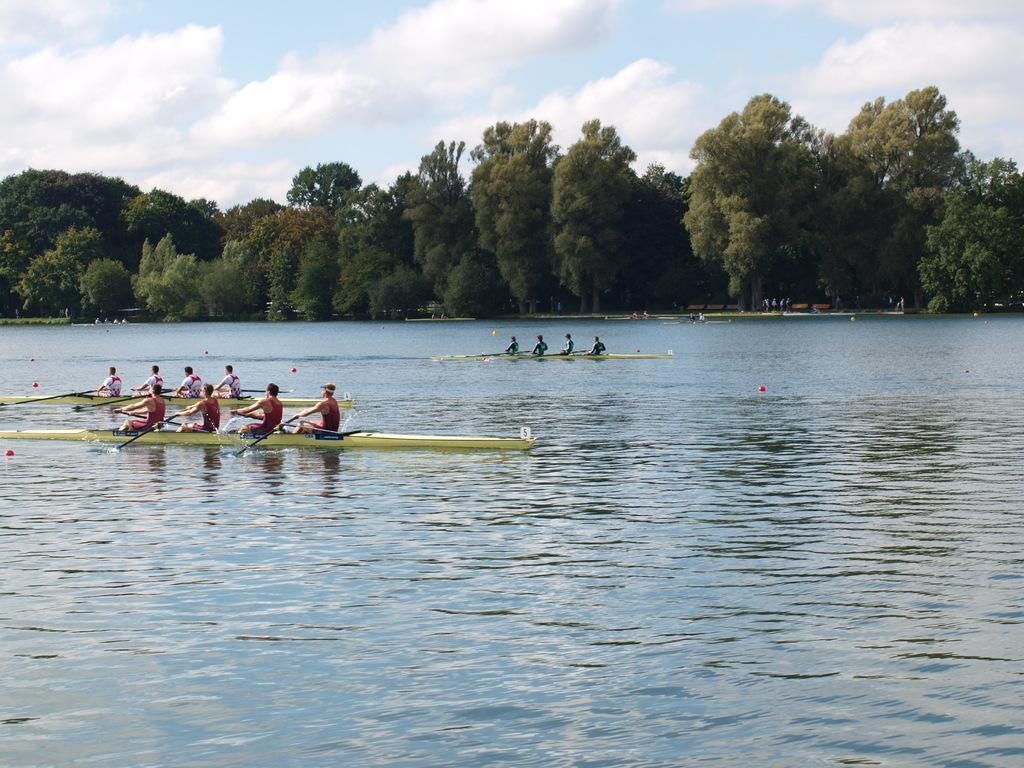In one or two sentences, can you explain what this image depicts? In this image there is water and we can see boats on the water. There are people sitting in the boats. In the background there are trees and sky. 